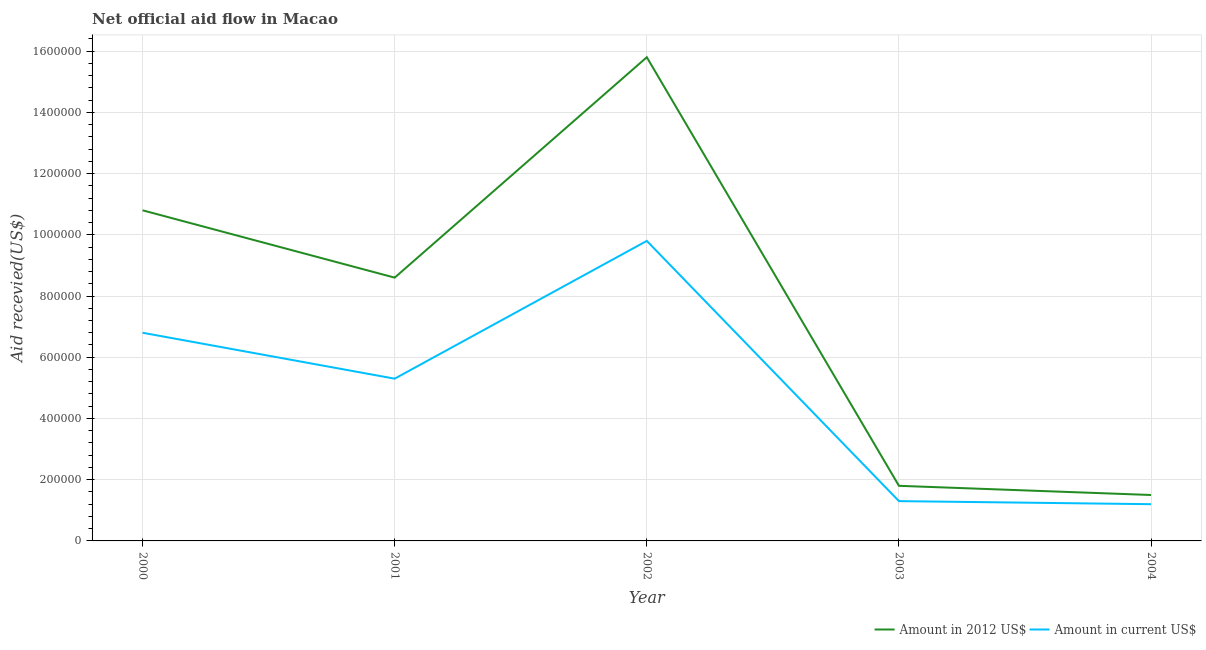How many different coloured lines are there?
Offer a terse response. 2. Is the number of lines equal to the number of legend labels?
Ensure brevity in your answer.  Yes. What is the amount of aid received(expressed in us$) in 2000?
Your answer should be compact. 6.80e+05. Across all years, what is the maximum amount of aid received(expressed in us$)?
Provide a succinct answer. 9.80e+05. Across all years, what is the minimum amount of aid received(expressed in us$)?
Ensure brevity in your answer.  1.20e+05. What is the total amount of aid received(expressed in 2012 us$) in the graph?
Offer a terse response. 3.85e+06. What is the difference between the amount of aid received(expressed in 2012 us$) in 2000 and that in 2004?
Make the answer very short. 9.30e+05. What is the difference between the amount of aid received(expressed in 2012 us$) in 2002 and the amount of aid received(expressed in us$) in 2000?
Ensure brevity in your answer.  9.00e+05. What is the average amount of aid received(expressed in 2012 us$) per year?
Ensure brevity in your answer.  7.70e+05. In the year 2000, what is the difference between the amount of aid received(expressed in us$) and amount of aid received(expressed in 2012 us$)?
Offer a very short reply. -4.00e+05. What is the ratio of the amount of aid received(expressed in us$) in 2001 to that in 2003?
Offer a very short reply. 4.08. Is the amount of aid received(expressed in us$) in 2001 less than that in 2003?
Offer a terse response. No. Is the difference between the amount of aid received(expressed in us$) in 2001 and 2004 greater than the difference between the amount of aid received(expressed in 2012 us$) in 2001 and 2004?
Ensure brevity in your answer.  No. What is the difference between the highest and the lowest amount of aid received(expressed in us$)?
Your answer should be compact. 8.60e+05. In how many years, is the amount of aid received(expressed in us$) greater than the average amount of aid received(expressed in us$) taken over all years?
Your answer should be very brief. 3. Is the sum of the amount of aid received(expressed in us$) in 2000 and 2001 greater than the maximum amount of aid received(expressed in 2012 us$) across all years?
Keep it short and to the point. No. Does the amount of aid received(expressed in 2012 us$) monotonically increase over the years?
Your answer should be very brief. No. Is the amount of aid received(expressed in 2012 us$) strictly less than the amount of aid received(expressed in us$) over the years?
Your answer should be compact. No. How many lines are there?
Provide a succinct answer. 2. How many years are there in the graph?
Provide a succinct answer. 5. What is the difference between two consecutive major ticks on the Y-axis?
Provide a succinct answer. 2.00e+05. Are the values on the major ticks of Y-axis written in scientific E-notation?
Keep it short and to the point. No. Where does the legend appear in the graph?
Your answer should be very brief. Bottom right. How are the legend labels stacked?
Provide a short and direct response. Horizontal. What is the title of the graph?
Provide a short and direct response. Net official aid flow in Macao. What is the label or title of the X-axis?
Keep it short and to the point. Year. What is the label or title of the Y-axis?
Give a very brief answer. Aid recevied(US$). What is the Aid recevied(US$) in Amount in 2012 US$ in 2000?
Provide a short and direct response. 1.08e+06. What is the Aid recevied(US$) in Amount in current US$ in 2000?
Offer a terse response. 6.80e+05. What is the Aid recevied(US$) of Amount in 2012 US$ in 2001?
Your answer should be compact. 8.60e+05. What is the Aid recevied(US$) of Amount in current US$ in 2001?
Give a very brief answer. 5.30e+05. What is the Aid recevied(US$) of Amount in 2012 US$ in 2002?
Your response must be concise. 1.58e+06. What is the Aid recevied(US$) of Amount in current US$ in 2002?
Make the answer very short. 9.80e+05. What is the Aid recevied(US$) of Amount in 2012 US$ in 2003?
Offer a very short reply. 1.80e+05. What is the Aid recevied(US$) of Amount in current US$ in 2003?
Your response must be concise. 1.30e+05. What is the Aid recevied(US$) of Amount in 2012 US$ in 2004?
Ensure brevity in your answer.  1.50e+05. Across all years, what is the maximum Aid recevied(US$) in Amount in 2012 US$?
Give a very brief answer. 1.58e+06. Across all years, what is the maximum Aid recevied(US$) of Amount in current US$?
Provide a short and direct response. 9.80e+05. What is the total Aid recevied(US$) in Amount in 2012 US$ in the graph?
Offer a terse response. 3.85e+06. What is the total Aid recevied(US$) of Amount in current US$ in the graph?
Give a very brief answer. 2.44e+06. What is the difference between the Aid recevied(US$) in Amount in 2012 US$ in 2000 and that in 2002?
Your answer should be compact. -5.00e+05. What is the difference between the Aid recevied(US$) in Amount in current US$ in 2000 and that in 2002?
Provide a short and direct response. -3.00e+05. What is the difference between the Aid recevied(US$) of Amount in 2012 US$ in 2000 and that in 2003?
Make the answer very short. 9.00e+05. What is the difference between the Aid recevied(US$) of Amount in current US$ in 2000 and that in 2003?
Your answer should be compact. 5.50e+05. What is the difference between the Aid recevied(US$) in Amount in 2012 US$ in 2000 and that in 2004?
Ensure brevity in your answer.  9.30e+05. What is the difference between the Aid recevied(US$) in Amount in current US$ in 2000 and that in 2004?
Provide a short and direct response. 5.60e+05. What is the difference between the Aid recevied(US$) of Amount in 2012 US$ in 2001 and that in 2002?
Provide a succinct answer. -7.20e+05. What is the difference between the Aid recevied(US$) of Amount in current US$ in 2001 and that in 2002?
Offer a terse response. -4.50e+05. What is the difference between the Aid recevied(US$) in Amount in 2012 US$ in 2001 and that in 2003?
Provide a short and direct response. 6.80e+05. What is the difference between the Aid recevied(US$) in Amount in 2012 US$ in 2001 and that in 2004?
Provide a short and direct response. 7.10e+05. What is the difference between the Aid recevied(US$) of Amount in 2012 US$ in 2002 and that in 2003?
Provide a succinct answer. 1.40e+06. What is the difference between the Aid recevied(US$) in Amount in current US$ in 2002 and that in 2003?
Offer a terse response. 8.50e+05. What is the difference between the Aid recevied(US$) of Amount in 2012 US$ in 2002 and that in 2004?
Offer a very short reply. 1.43e+06. What is the difference between the Aid recevied(US$) in Amount in current US$ in 2002 and that in 2004?
Your response must be concise. 8.60e+05. What is the difference between the Aid recevied(US$) in Amount in 2012 US$ in 2003 and that in 2004?
Your answer should be very brief. 3.00e+04. What is the difference between the Aid recevied(US$) in Amount in current US$ in 2003 and that in 2004?
Give a very brief answer. 10000. What is the difference between the Aid recevied(US$) in Amount in 2012 US$ in 2000 and the Aid recevied(US$) in Amount in current US$ in 2003?
Your answer should be very brief. 9.50e+05. What is the difference between the Aid recevied(US$) in Amount in 2012 US$ in 2000 and the Aid recevied(US$) in Amount in current US$ in 2004?
Your answer should be compact. 9.60e+05. What is the difference between the Aid recevied(US$) in Amount in 2012 US$ in 2001 and the Aid recevied(US$) in Amount in current US$ in 2003?
Keep it short and to the point. 7.30e+05. What is the difference between the Aid recevied(US$) of Amount in 2012 US$ in 2001 and the Aid recevied(US$) of Amount in current US$ in 2004?
Give a very brief answer. 7.40e+05. What is the difference between the Aid recevied(US$) in Amount in 2012 US$ in 2002 and the Aid recevied(US$) in Amount in current US$ in 2003?
Offer a very short reply. 1.45e+06. What is the difference between the Aid recevied(US$) of Amount in 2012 US$ in 2002 and the Aid recevied(US$) of Amount in current US$ in 2004?
Offer a very short reply. 1.46e+06. What is the difference between the Aid recevied(US$) of Amount in 2012 US$ in 2003 and the Aid recevied(US$) of Amount in current US$ in 2004?
Ensure brevity in your answer.  6.00e+04. What is the average Aid recevied(US$) of Amount in 2012 US$ per year?
Your answer should be very brief. 7.70e+05. What is the average Aid recevied(US$) of Amount in current US$ per year?
Your answer should be compact. 4.88e+05. In the year 2000, what is the difference between the Aid recevied(US$) in Amount in 2012 US$ and Aid recevied(US$) in Amount in current US$?
Offer a very short reply. 4.00e+05. In the year 2001, what is the difference between the Aid recevied(US$) in Amount in 2012 US$ and Aid recevied(US$) in Amount in current US$?
Your answer should be compact. 3.30e+05. In the year 2002, what is the difference between the Aid recevied(US$) in Amount in 2012 US$ and Aid recevied(US$) in Amount in current US$?
Keep it short and to the point. 6.00e+05. In the year 2004, what is the difference between the Aid recevied(US$) in Amount in 2012 US$ and Aid recevied(US$) in Amount in current US$?
Your answer should be compact. 3.00e+04. What is the ratio of the Aid recevied(US$) in Amount in 2012 US$ in 2000 to that in 2001?
Provide a short and direct response. 1.26. What is the ratio of the Aid recevied(US$) of Amount in current US$ in 2000 to that in 2001?
Give a very brief answer. 1.28. What is the ratio of the Aid recevied(US$) in Amount in 2012 US$ in 2000 to that in 2002?
Your response must be concise. 0.68. What is the ratio of the Aid recevied(US$) of Amount in current US$ in 2000 to that in 2002?
Your response must be concise. 0.69. What is the ratio of the Aid recevied(US$) of Amount in current US$ in 2000 to that in 2003?
Offer a very short reply. 5.23. What is the ratio of the Aid recevied(US$) in Amount in current US$ in 2000 to that in 2004?
Provide a succinct answer. 5.67. What is the ratio of the Aid recevied(US$) of Amount in 2012 US$ in 2001 to that in 2002?
Your answer should be very brief. 0.54. What is the ratio of the Aid recevied(US$) of Amount in current US$ in 2001 to that in 2002?
Your answer should be compact. 0.54. What is the ratio of the Aid recevied(US$) in Amount in 2012 US$ in 2001 to that in 2003?
Ensure brevity in your answer.  4.78. What is the ratio of the Aid recevied(US$) of Amount in current US$ in 2001 to that in 2003?
Your answer should be compact. 4.08. What is the ratio of the Aid recevied(US$) of Amount in 2012 US$ in 2001 to that in 2004?
Make the answer very short. 5.73. What is the ratio of the Aid recevied(US$) of Amount in current US$ in 2001 to that in 2004?
Provide a succinct answer. 4.42. What is the ratio of the Aid recevied(US$) in Amount in 2012 US$ in 2002 to that in 2003?
Give a very brief answer. 8.78. What is the ratio of the Aid recevied(US$) of Amount in current US$ in 2002 to that in 2003?
Your response must be concise. 7.54. What is the ratio of the Aid recevied(US$) in Amount in 2012 US$ in 2002 to that in 2004?
Give a very brief answer. 10.53. What is the ratio of the Aid recevied(US$) in Amount in current US$ in 2002 to that in 2004?
Make the answer very short. 8.17. What is the ratio of the Aid recevied(US$) in Amount in 2012 US$ in 2003 to that in 2004?
Your answer should be very brief. 1.2. What is the difference between the highest and the lowest Aid recevied(US$) of Amount in 2012 US$?
Offer a terse response. 1.43e+06. What is the difference between the highest and the lowest Aid recevied(US$) in Amount in current US$?
Provide a short and direct response. 8.60e+05. 